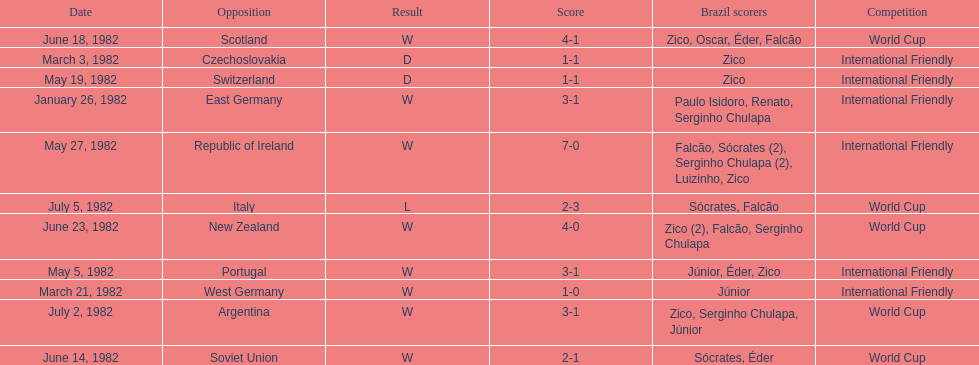What date is at the top of the list? January 26, 1982. 